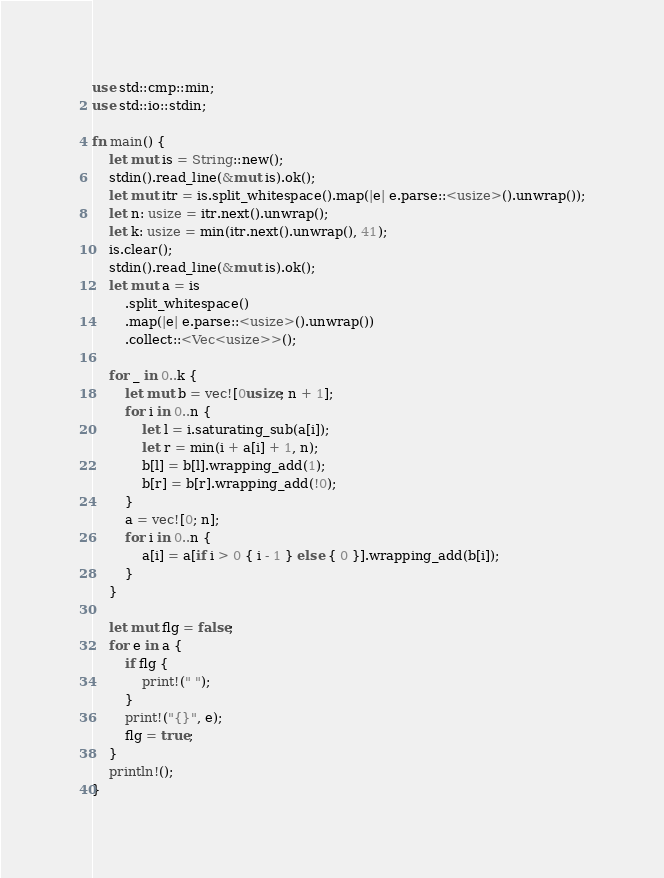Convert code to text. <code><loc_0><loc_0><loc_500><loc_500><_Rust_>use std::cmp::min;
use std::io::stdin;

fn main() {
    let mut is = String::new();
    stdin().read_line(&mut is).ok();
    let mut itr = is.split_whitespace().map(|e| e.parse::<usize>().unwrap());
    let n: usize = itr.next().unwrap();
    let k: usize = min(itr.next().unwrap(), 41);
    is.clear();
    stdin().read_line(&mut is).ok();
    let mut a = is
        .split_whitespace()
        .map(|e| e.parse::<usize>().unwrap())
        .collect::<Vec<usize>>();

    for _ in 0..k {
        let mut b = vec![0usize; n + 1];
        for i in 0..n {
            let l = i.saturating_sub(a[i]);
            let r = min(i + a[i] + 1, n);
            b[l] = b[l].wrapping_add(1);
            b[r] = b[r].wrapping_add(!0);
        }
        a = vec![0; n];
        for i in 0..n {
            a[i] = a[if i > 0 { i - 1 } else { 0 }].wrapping_add(b[i]);
        }
    }

    let mut flg = false;
    for e in a {
        if flg {
            print!(" ");
        }
        print!("{}", e);
        flg = true;
    }
    println!();
}
</code> 